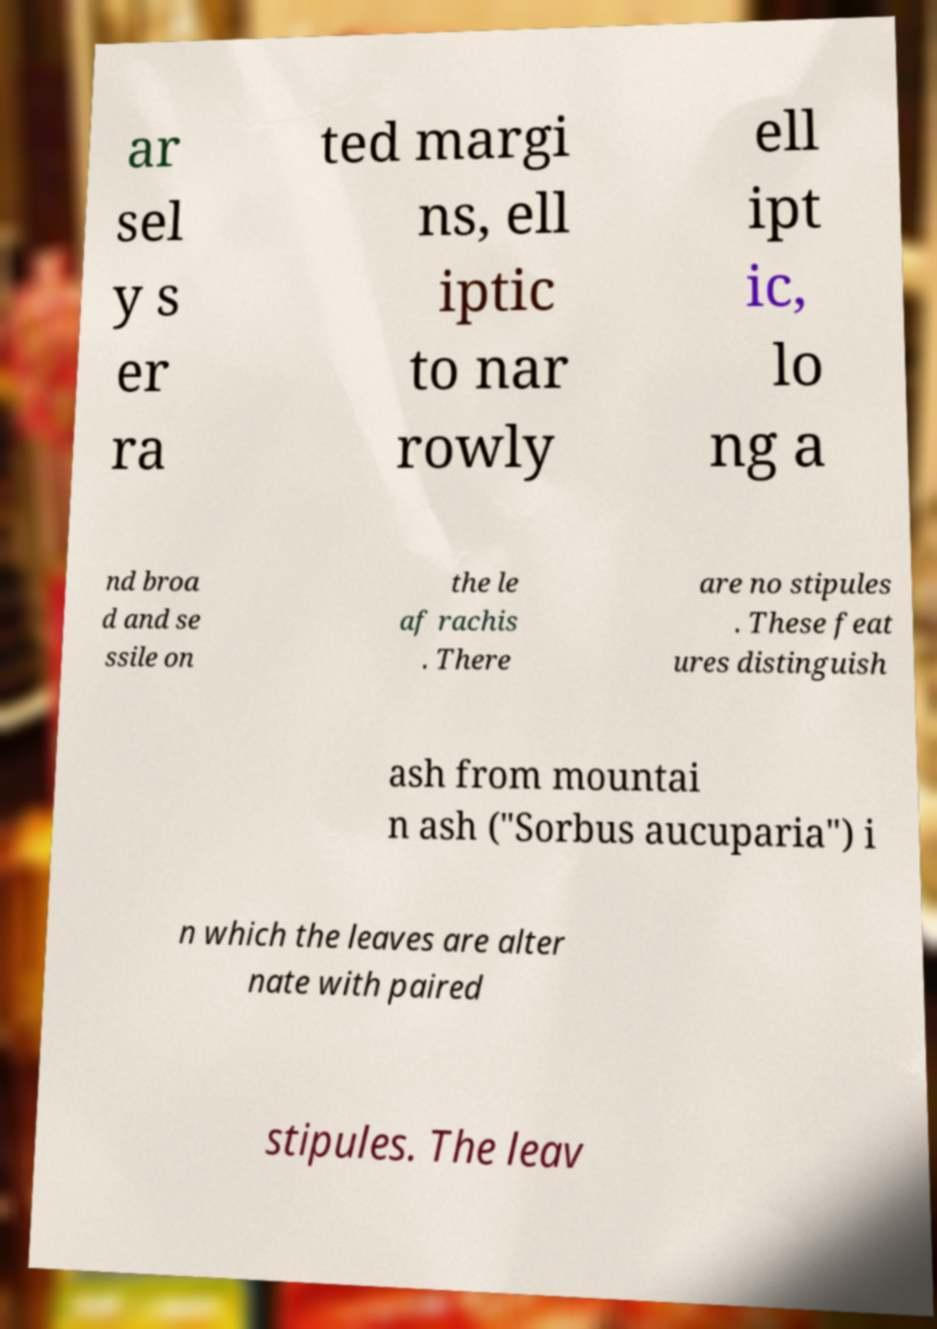For documentation purposes, I need the text within this image transcribed. Could you provide that? ar sel y s er ra ted margi ns, ell iptic to nar rowly ell ipt ic, lo ng a nd broa d and se ssile on the le af rachis . There are no stipules . These feat ures distinguish ash from mountai n ash ("Sorbus aucuparia") i n which the leaves are alter nate with paired stipules. The leav 